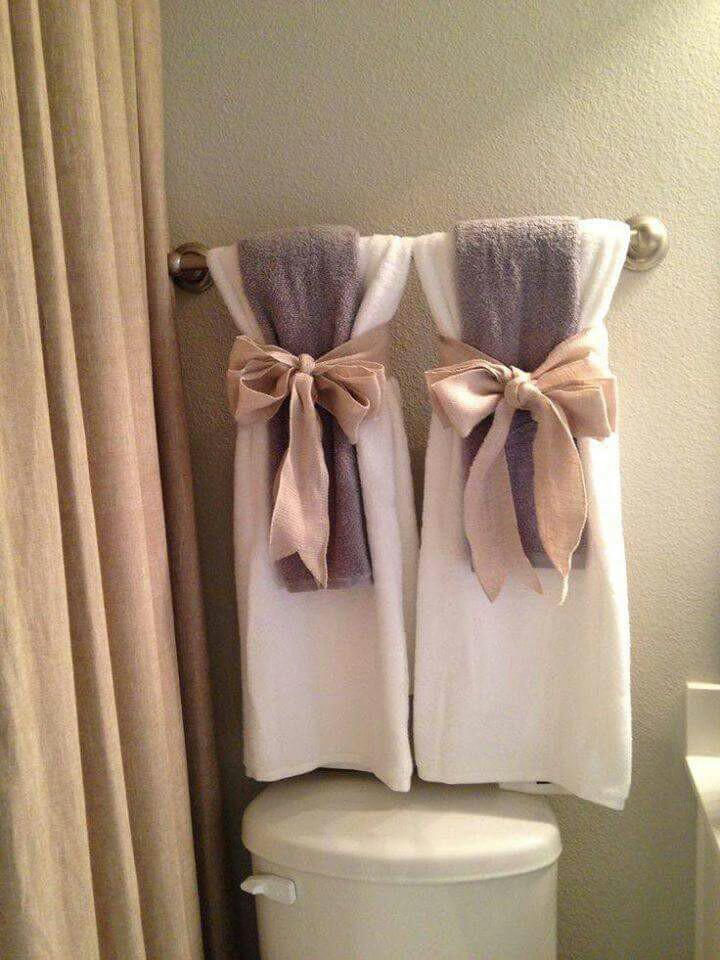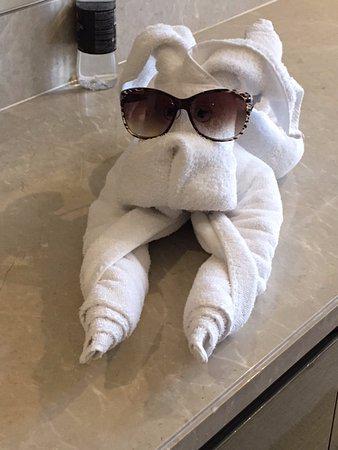The first image is the image on the left, the second image is the image on the right. Analyze the images presented: Is the assertion "A picture is hanging on the wall above some towels." valid? Answer yes or no. No. The first image is the image on the left, the second image is the image on the right. Analyze the images presented: Is the assertion "Right image features side-by-side towels arranged decoratively on a bar." valid? Answer yes or no. No. 